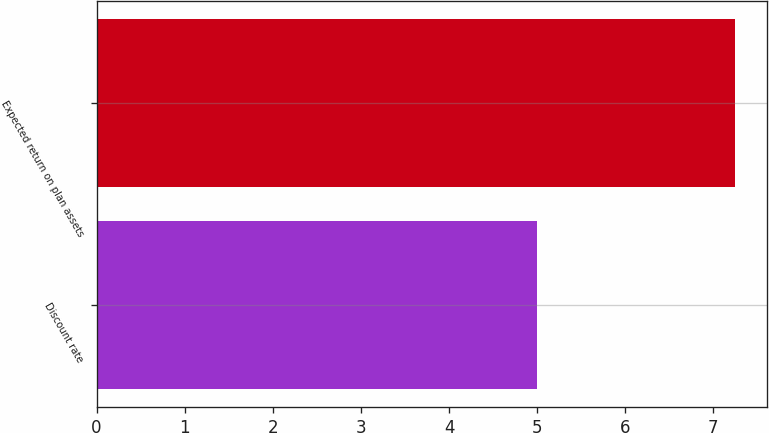Convert chart. <chart><loc_0><loc_0><loc_500><loc_500><bar_chart><fcel>Discount rate<fcel>Expected return on plan assets<nl><fcel>5<fcel>7.25<nl></chart> 